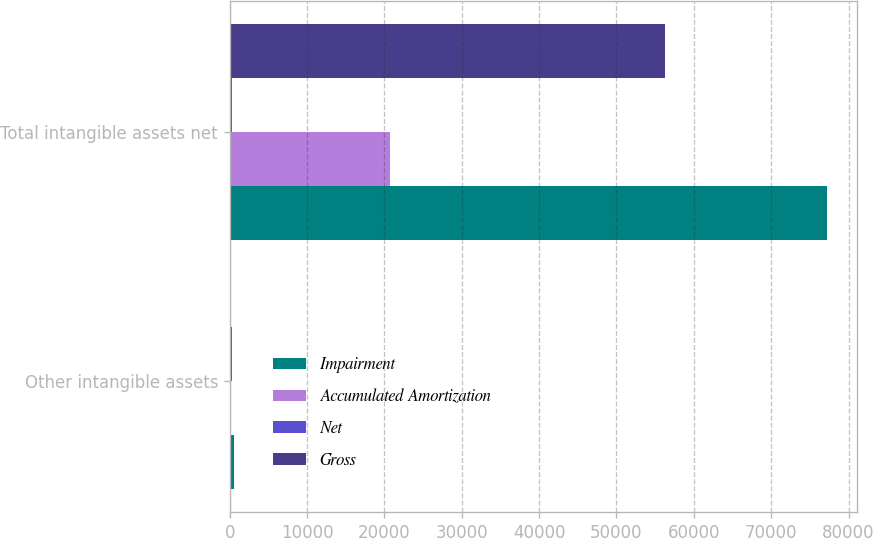<chart> <loc_0><loc_0><loc_500><loc_500><stacked_bar_chart><ecel><fcel>Other intangible assets<fcel>Total intangible assets net<nl><fcel>Impairment<fcel>500<fcel>77188<nl><fcel>Accumulated Amortization<fcel>172<fcel>20673<nl><fcel>Net<fcel>291<fcel>291<nl><fcel>Gross<fcel>37<fcel>56224<nl></chart> 